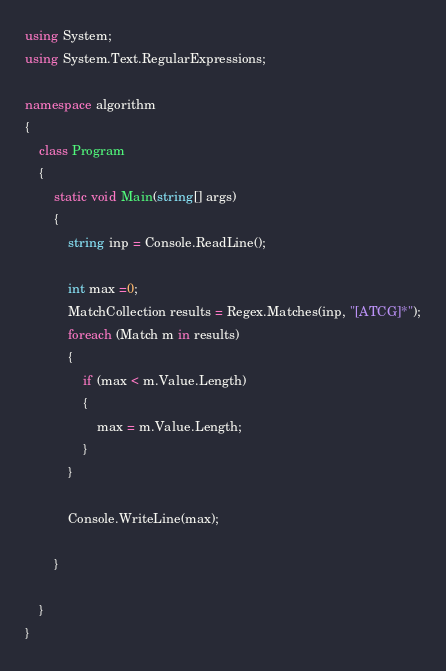Convert code to text. <code><loc_0><loc_0><loc_500><loc_500><_C#_>using System;
using System.Text.RegularExpressions;

namespace algorithm
{
	class Program
	{
		static void Main(string[] args)
		{
			string inp = Console.ReadLine();

			int max =0;
			MatchCollection results = Regex.Matches(inp, "[ATCG]*");
			foreach (Match m in results)
			{
				if (max < m.Value.Length)
				{
					max = m.Value.Length;
				}
			}

			Console.WriteLine(max);

		}

	}
}
</code> 